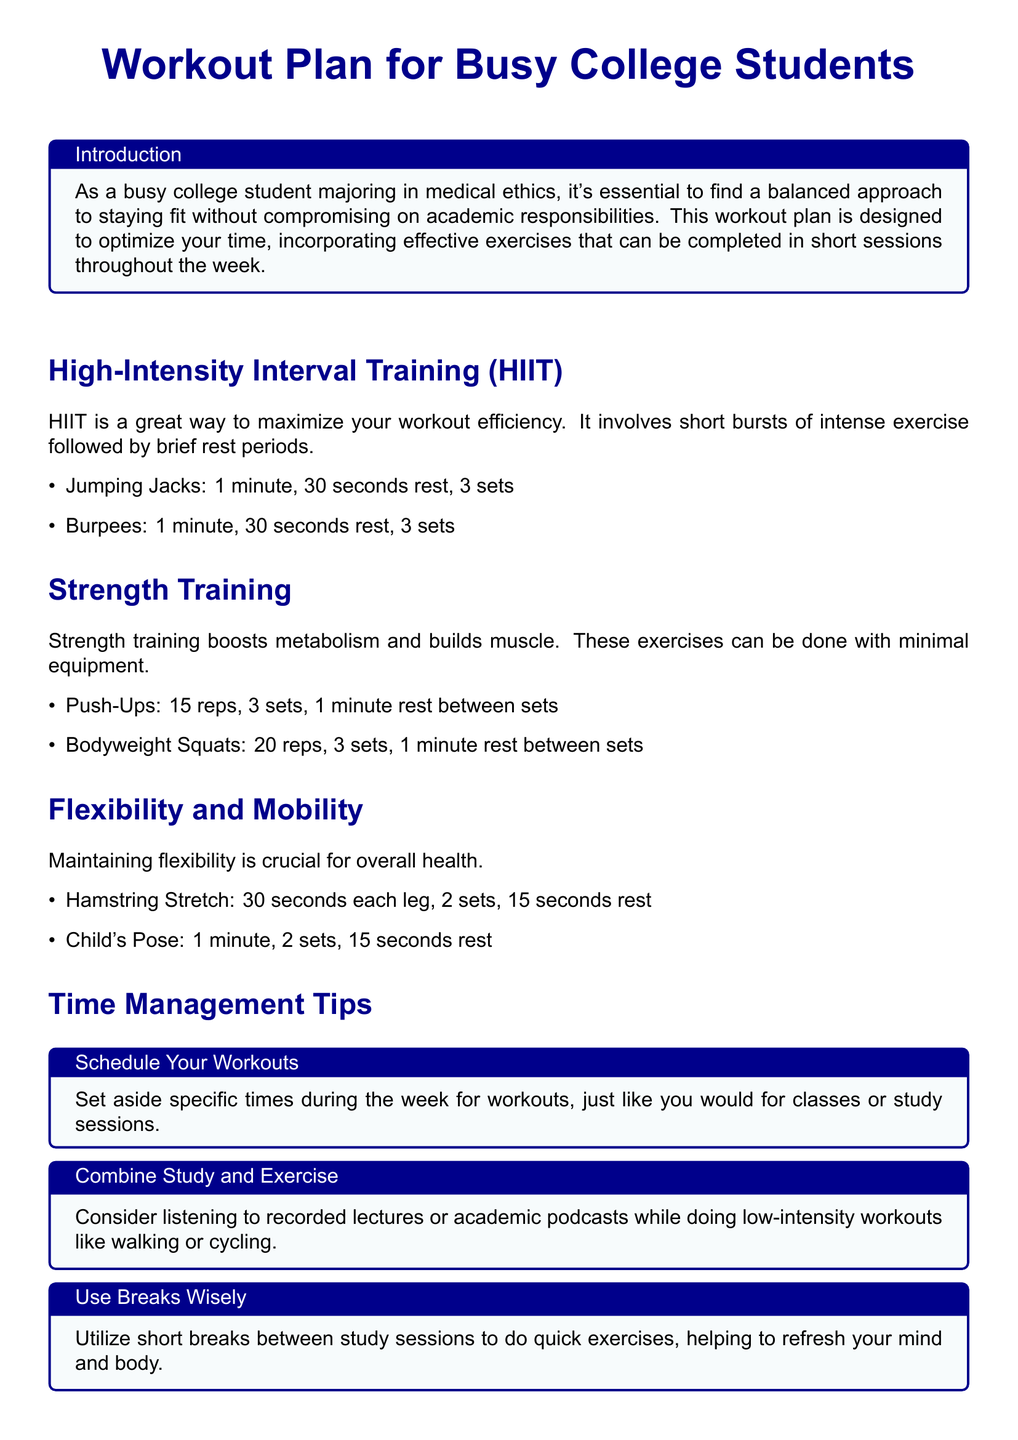What are the suggested exercises in HIIT? The document lists Jumping Jacks and Burpees as exercises for HIIT.
Answer: Jumping Jacks and Burpees How long is each HIIT exercise? Each exercise in HIIT is performed for 1 minute.
Answer: 1 minute What is the recommended rest time after HIIT exercises? The rest time after HIIT exercises is 30 seconds.
Answer: 30 seconds How many reps of Push-Ups are suggested? The document suggests performing 15 reps of Push-Ups.
Answer: 15 reps What is the primary focus of the Flexibility and Mobility section? The primary focus is on maintaining flexibility for overall health.
Answer: Maintaining flexibility What is one of the time management tips mentioned? One of the tips is to combine study and exercise by listening to lectures while working out.
Answer: Combine Study and Exercise How many sets are recommended for the Hamstring Stretch? The document recommends 2 sets for the Hamstring Stretch.
Answer: 2 sets What is emphasized as key to staying fit in college? Consistency is emphasized as key to staying fit.
Answer: Consistency 